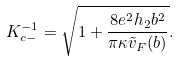Convert formula to latex. <formula><loc_0><loc_0><loc_500><loc_500>K _ { c - } ^ { - 1 } = \sqrt { 1 + \frac { 8 e ^ { 2 } h _ { 2 } b ^ { 2 } } { \pi \kappa \tilde { v } _ { F } ( b ) } } .</formula> 